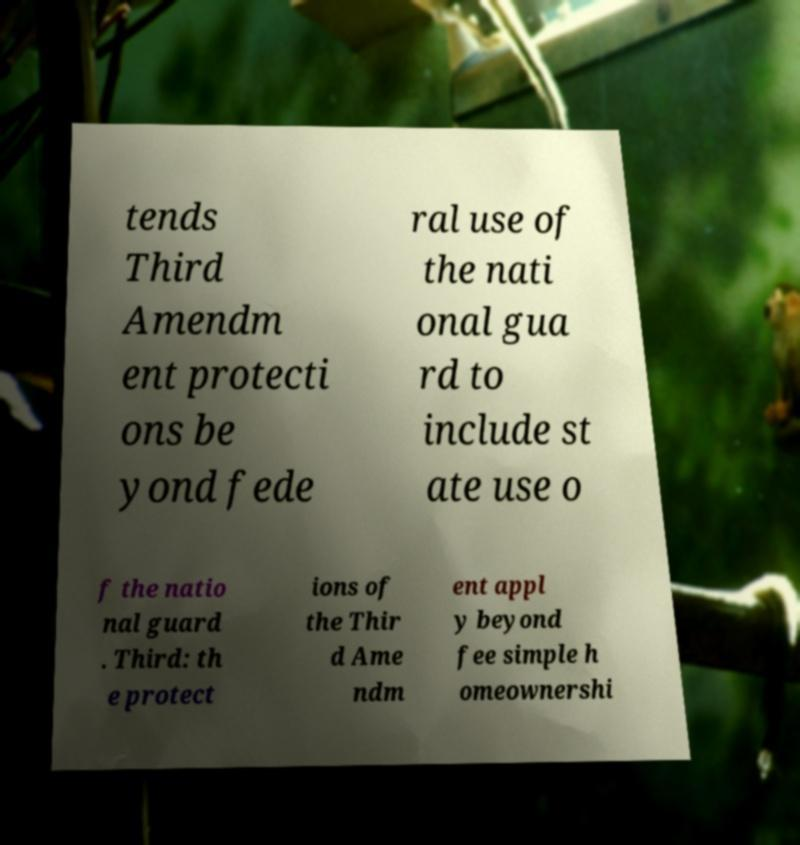Can you read and provide the text displayed in the image?This photo seems to have some interesting text. Can you extract and type it out for me? tends Third Amendm ent protecti ons be yond fede ral use of the nati onal gua rd to include st ate use o f the natio nal guard . Third: th e protect ions of the Thir d Ame ndm ent appl y beyond fee simple h omeownershi 